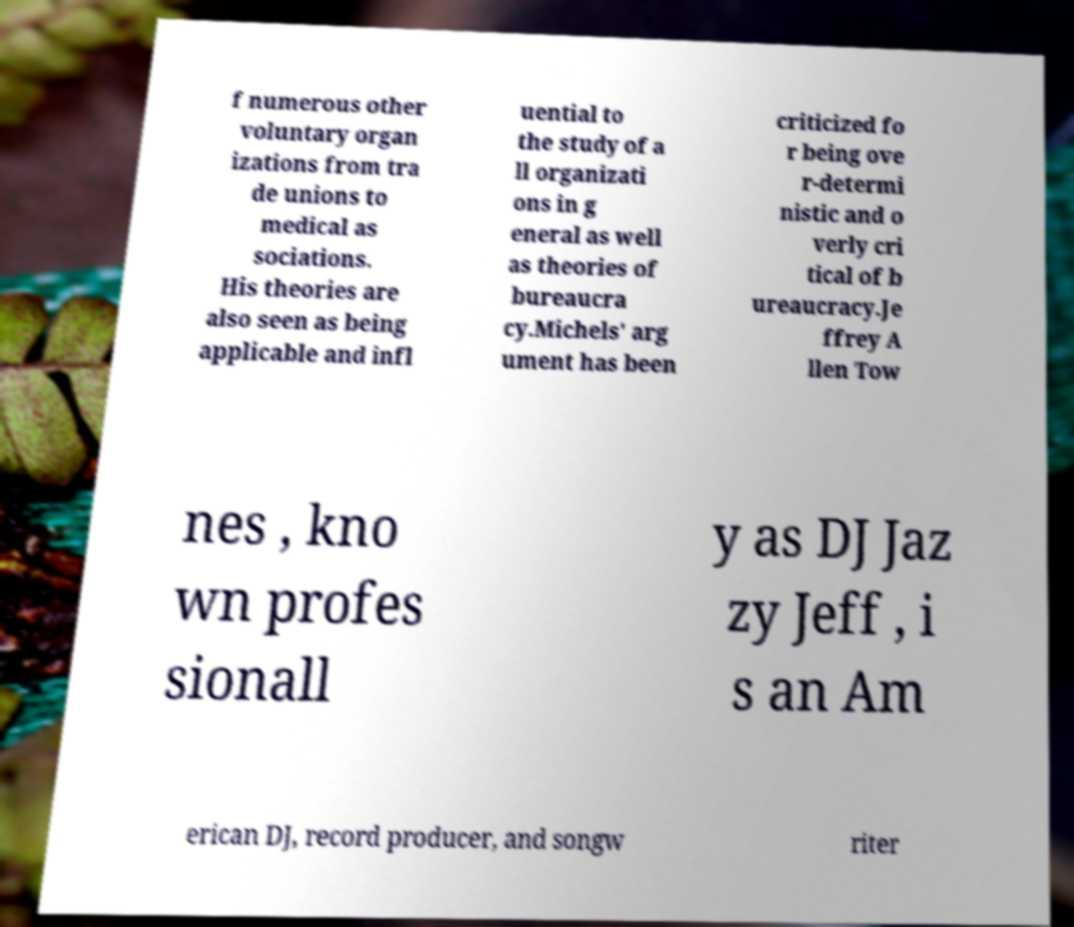Could you assist in decoding the text presented in this image and type it out clearly? f numerous other voluntary organ izations from tra de unions to medical as sociations. His theories are also seen as being applicable and infl uential to the study of a ll organizati ons in g eneral as well as theories of bureaucra cy.Michels' arg ument has been criticized fo r being ove r-determi nistic and o verly cri tical of b ureaucracy.Je ffrey A llen Tow nes , kno wn profes sionall y as DJ Jaz zy Jeff , i s an Am erican DJ, record producer, and songw riter 